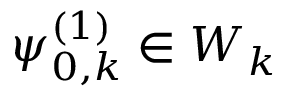<formula> <loc_0><loc_0><loc_500><loc_500>\psi _ { 0 , k } ^ { ( 1 ) } \in W _ { k }</formula> 